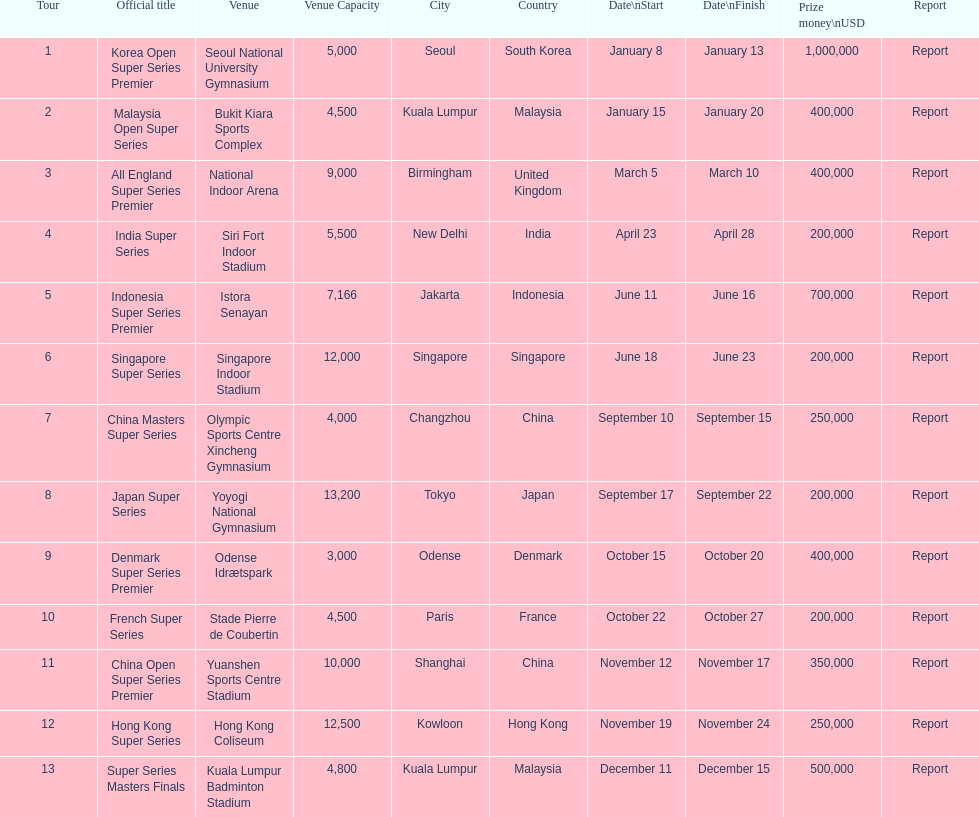Which series has the highest prize payout? Korea Open Super Series Premier. 